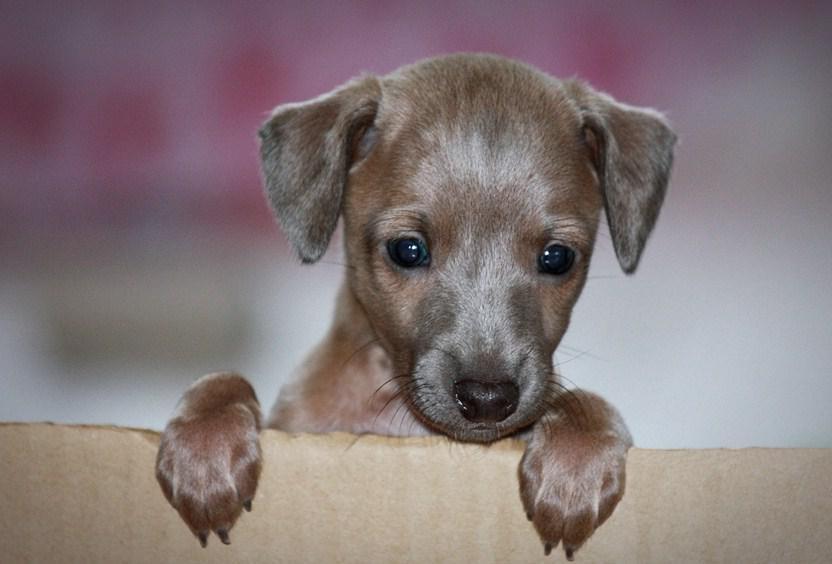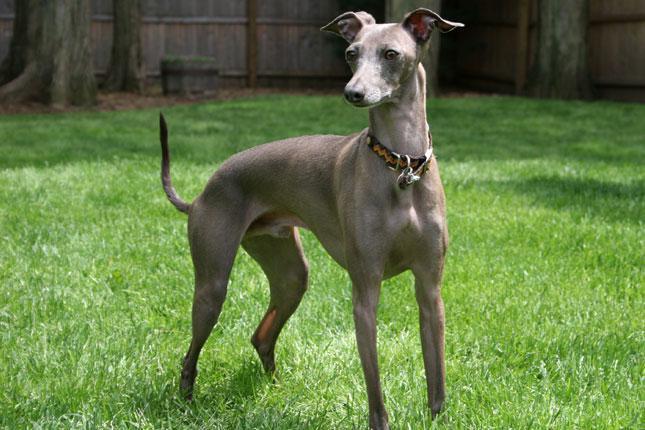The first image is the image on the left, the second image is the image on the right. Considering the images on both sides, is "There is a fence behind a dog." valid? Answer yes or no. Yes. The first image is the image on the left, the second image is the image on the right. Given the left and right images, does the statement "In 1 of the images, 1 dog is facing forward indoors." hold true? Answer yes or no. Yes. 